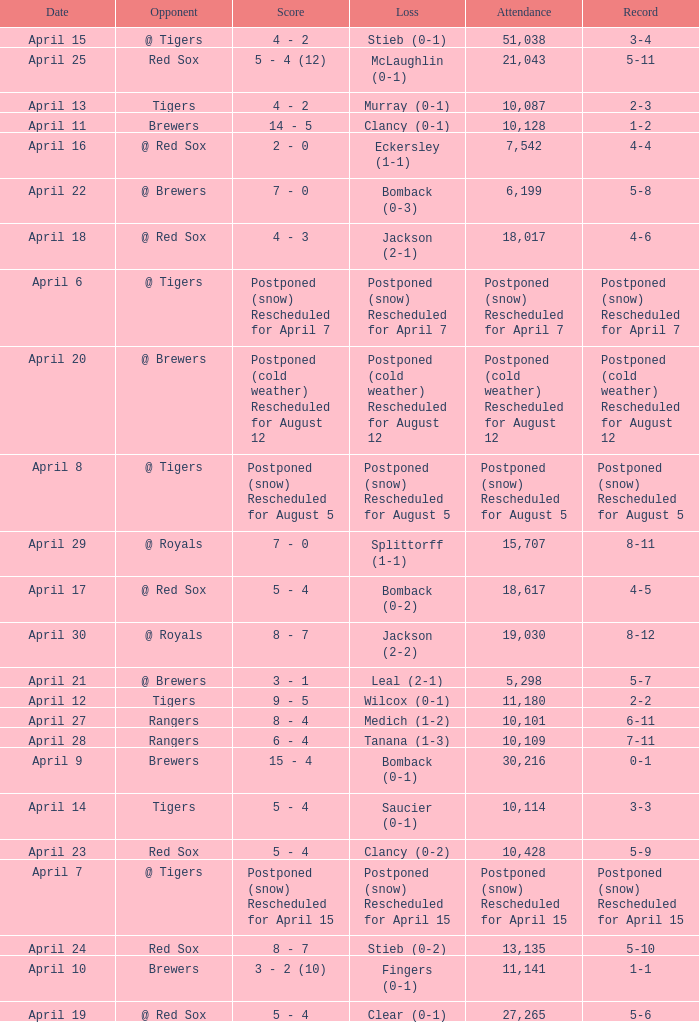Which record is dated April 8? Postponed (snow) Rescheduled for August 5. 